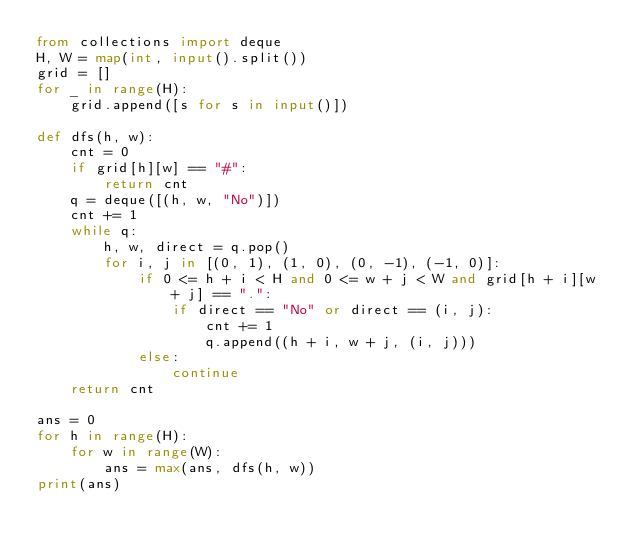Convert code to text. <code><loc_0><loc_0><loc_500><loc_500><_Python_>from collections import deque
H, W = map(int, input().split())
grid = []
for _ in range(H):
    grid.append([s for s in input()])

def dfs(h, w):
    cnt = 0
    if grid[h][w] == "#":
        return cnt
    q = deque([(h, w, "No")])
    cnt += 1
    while q:
        h, w, direct = q.pop()
        for i, j in [(0, 1), (1, 0), (0, -1), (-1, 0)]:
            if 0 <= h + i < H and 0 <= w + j < W and grid[h + i][w + j] == ".":
                if direct == "No" or direct == (i, j):
                    cnt += 1
                    q.append((h + i, w + j, (i, j)))
            else:
                continue
    return cnt 
    
ans = 0
for h in range(H):
    for w in range(W):
        ans = max(ans, dfs(h, w))
print(ans)</code> 